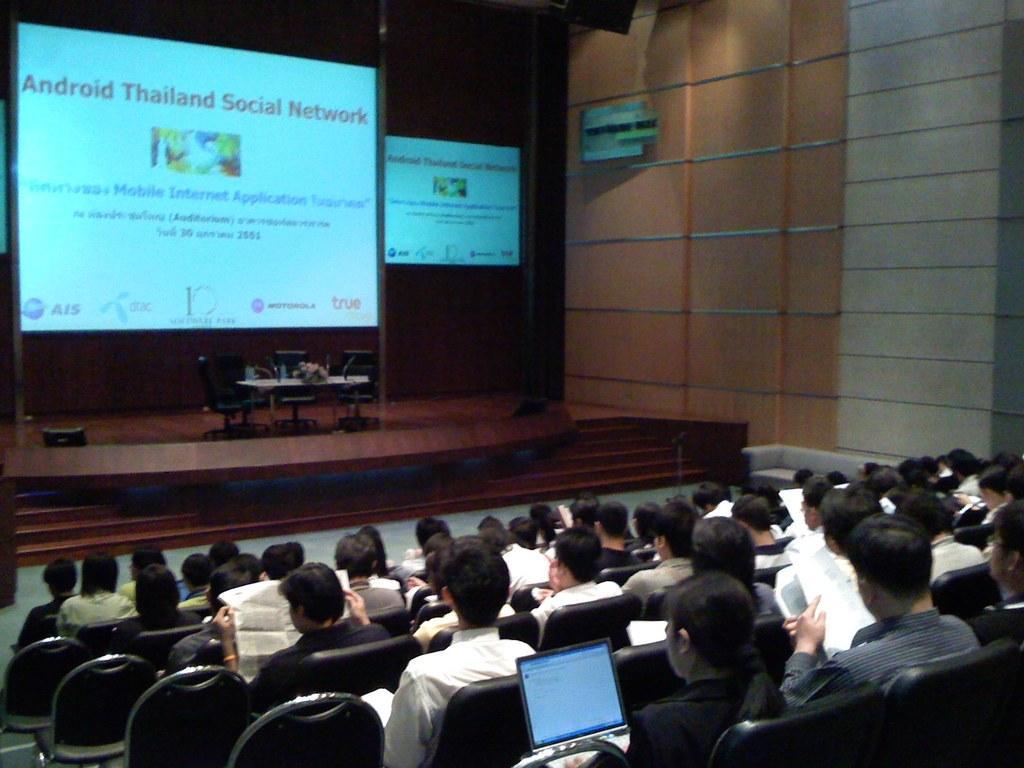Can you describe this image briefly? In this image there are a few people sitting in chairs are holding laptops and papers in their hands, in front of them on the stage there are a few empty chairs, in front of the chairs there is a table with some objects on it, behind the chairs there are two screens on the wall, on the right side of the image there is a wall, in front of the stage there are stairs. 